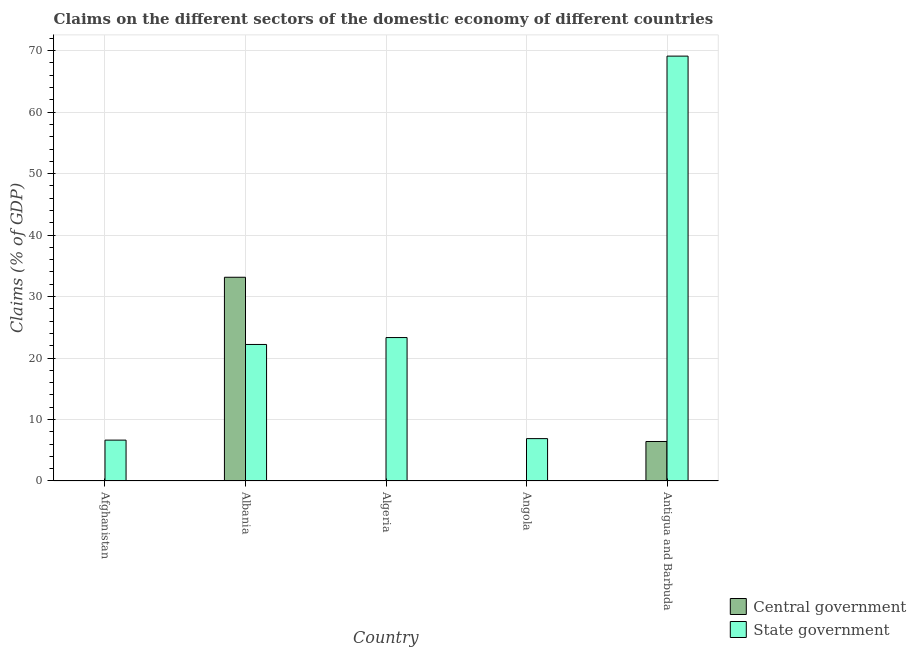Are the number of bars on each tick of the X-axis equal?
Give a very brief answer. No. How many bars are there on the 2nd tick from the left?
Offer a very short reply. 2. What is the label of the 5th group of bars from the left?
Offer a terse response. Antigua and Barbuda. In how many cases, is the number of bars for a given country not equal to the number of legend labels?
Keep it short and to the point. 3. What is the claims on state government in Angola?
Provide a short and direct response. 6.89. Across all countries, what is the maximum claims on state government?
Provide a short and direct response. 69.12. Across all countries, what is the minimum claims on state government?
Offer a very short reply. 6.65. In which country was the claims on central government maximum?
Ensure brevity in your answer.  Albania. What is the total claims on central government in the graph?
Your response must be concise. 39.57. What is the difference between the claims on state government in Albania and that in Antigua and Barbuda?
Offer a terse response. -46.91. What is the difference between the claims on state government in Angola and the claims on central government in Afghanistan?
Ensure brevity in your answer.  6.89. What is the average claims on central government per country?
Provide a succinct answer. 7.91. What is the difference between the claims on central government and claims on state government in Albania?
Give a very brief answer. 10.93. In how many countries, is the claims on state government greater than 20 %?
Ensure brevity in your answer.  3. What is the ratio of the claims on state government in Albania to that in Angola?
Ensure brevity in your answer.  3.22. Is the claims on state government in Afghanistan less than that in Angola?
Keep it short and to the point. Yes. What is the difference between the highest and the second highest claims on state government?
Make the answer very short. 45.78. What is the difference between the highest and the lowest claims on central government?
Provide a short and direct response. 33.14. Is the sum of the claims on state government in Algeria and Angola greater than the maximum claims on central government across all countries?
Keep it short and to the point. No. Does the graph contain any zero values?
Offer a very short reply. Yes. Does the graph contain grids?
Your answer should be compact. Yes. What is the title of the graph?
Your response must be concise. Claims on the different sectors of the domestic economy of different countries. Does "% of gross capital formation" appear as one of the legend labels in the graph?
Give a very brief answer. No. What is the label or title of the Y-axis?
Offer a very short reply. Claims (% of GDP). What is the Claims (% of GDP) of State government in Afghanistan?
Provide a succinct answer. 6.65. What is the Claims (% of GDP) of Central government in Albania?
Provide a short and direct response. 33.14. What is the Claims (% of GDP) in State government in Albania?
Offer a terse response. 22.21. What is the Claims (% of GDP) of State government in Algeria?
Your answer should be compact. 23.33. What is the Claims (% of GDP) of Central government in Angola?
Provide a succinct answer. 0. What is the Claims (% of GDP) in State government in Angola?
Keep it short and to the point. 6.89. What is the Claims (% of GDP) in Central government in Antigua and Barbuda?
Provide a succinct answer. 6.43. What is the Claims (% of GDP) in State government in Antigua and Barbuda?
Provide a short and direct response. 69.12. Across all countries, what is the maximum Claims (% of GDP) of Central government?
Provide a short and direct response. 33.14. Across all countries, what is the maximum Claims (% of GDP) in State government?
Make the answer very short. 69.12. Across all countries, what is the minimum Claims (% of GDP) of State government?
Ensure brevity in your answer.  6.65. What is the total Claims (% of GDP) of Central government in the graph?
Keep it short and to the point. 39.57. What is the total Claims (% of GDP) of State government in the graph?
Keep it short and to the point. 128.21. What is the difference between the Claims (% of GDP) of State government in Afghanistan and that in Albania?
Ensure brevity in your answer.  -15.56. What is the difference between the Claims (% of GDP) of State government in Afghanistan and that in Algeria?
Your answer should be compact. -16.68. What is the difference between the Claims (% of GDP) in State government in Afghanistan and that in Angola?
Your answer should be very brief. -0.24. What is the difference between the Claims (% of GDP) in State government in Afghanistan and that in Antigua and Barbuda?
Offer a terse response. -62.47. What is the difference between the Claims (% of GDP) in State government in Albania and that in Algeria?
Your answer should be very brief. -1.12. What is the difference between the Claims (% of GDP) of State government in Albania and that in Angola?
Your answer should be very brief. 15.32. What is the difference between the Claims (% of GDP) of Central government in Albania and that in Antigua and Barbuda?
Your answer should be very brief. 26.72. What is the difference between the Claims (% of GDP) of State government in Albania and that in Antigua and Barbuda?
Give a very brief answer. -46.91. What is the difference between the Claims (% of GDP) of State government in Algeria and that in Angola?
Your answer should be compact. 16.44. What is the difference between the Claims (% of GDP) of State government in Algeria and that in Antigua and Barbuda?
Your answer should be very brief. -45.78. What is the difference between the Claims (% of GDP) of State government in Angola and that in Antigua and Barbuda?
Offer a very short reply. -62.22. What is the difference between the Claims (% of GDP) in Central government in Albania and the Claims (% of GDP) in State government in Algeria?
Make the answer very short. 9.81. What is the difference between the Claims (% of GDP) of Central government in Albania and the Claims (% of GDP) of State government in Angola?
Make the answer very short. 26.25. What is the difference between the Claims (% of GDP) in Central government in Albania and the Claims (% of GDP) in State government in Antigua and Barbuda?
Ensure brevity in your answer.  -35.97. What is the average Claims (% of GDP) of Central government per country?
Your answer should be very brief. 7.91. What is the average Claims (% of GDP) in State government per country?
Keep it short and to the point. 25.64. What is the difference between the Claims (% of GDP) of Central government and Claims (% of GDP) of State government in Albania?
Offer a very short reply. 10.93. What is the difference between the Claims (% of GDP) of Central government and Claims (% of GDP) of State government in Antigua and Barbuda?
Give a very brief answer. -62.69. What is the ratio of the Claims (% of GDP) of State government in Afghanistan to that in Albania?
Your response must be concise. 0.3. What is the ratio of the Claims (% of GDP) in State government in Afghanistan to that in Algeria?
Your answer should be compact. 0.28. What is the ratio of the Claims (% of GDP) in State government in Afghanistan to that in Angola?
Give a very brief answer. 0.96. What is the ratio of the Claims (% of GDP) of State government in Afghanistan to that in Antigua and Barbuda?
Ensure brevity in your answer.  0.1. What is the ratio of the Claims (% of GDP) of State government in Albania to that in Algeria?
Your response must be concise. 0.95. What is the ratio of the Claims (% of GDP) of State government in Albania to that in Angola?
Your answer should be very brief. 3.22. What is the ratio of the Claims (% of GDP) in Central government in Albania to that in Antigua and Barbuda?
Keep it short and to the point. 5.16. What is the ratio of the Claims (% of GDP) of State government in Albania to that in Antigua and Barbuda?
Offer a terse response. 0.32. What is the ratio of the Claims (% of GDP) in State government in Algeria to that in Angola?
Provide a succinct answer. 3.38. What is the ratio of the Claims (% of GDP) of State government in Algeria to that in Antigua and Barbuda?
Your response must be concise. 0.34. What is the ratio of the Claims (% of GDP) in State government in Angola to that in Antigua and Barbuda?
Give a very brief answer. 0.1. What is the difference between the highest and the second highest Claims (% of GDP) in State government?
Your answer should be very brief. 45.78. What is the difference between the highest and the lowest Claims (% of GDP) of Central government?
Your answer should be compact. 33.14. What is the difference between the highest and the lowest Claims (% of GDP) in State government?
Make the answer very short. 62.47. 